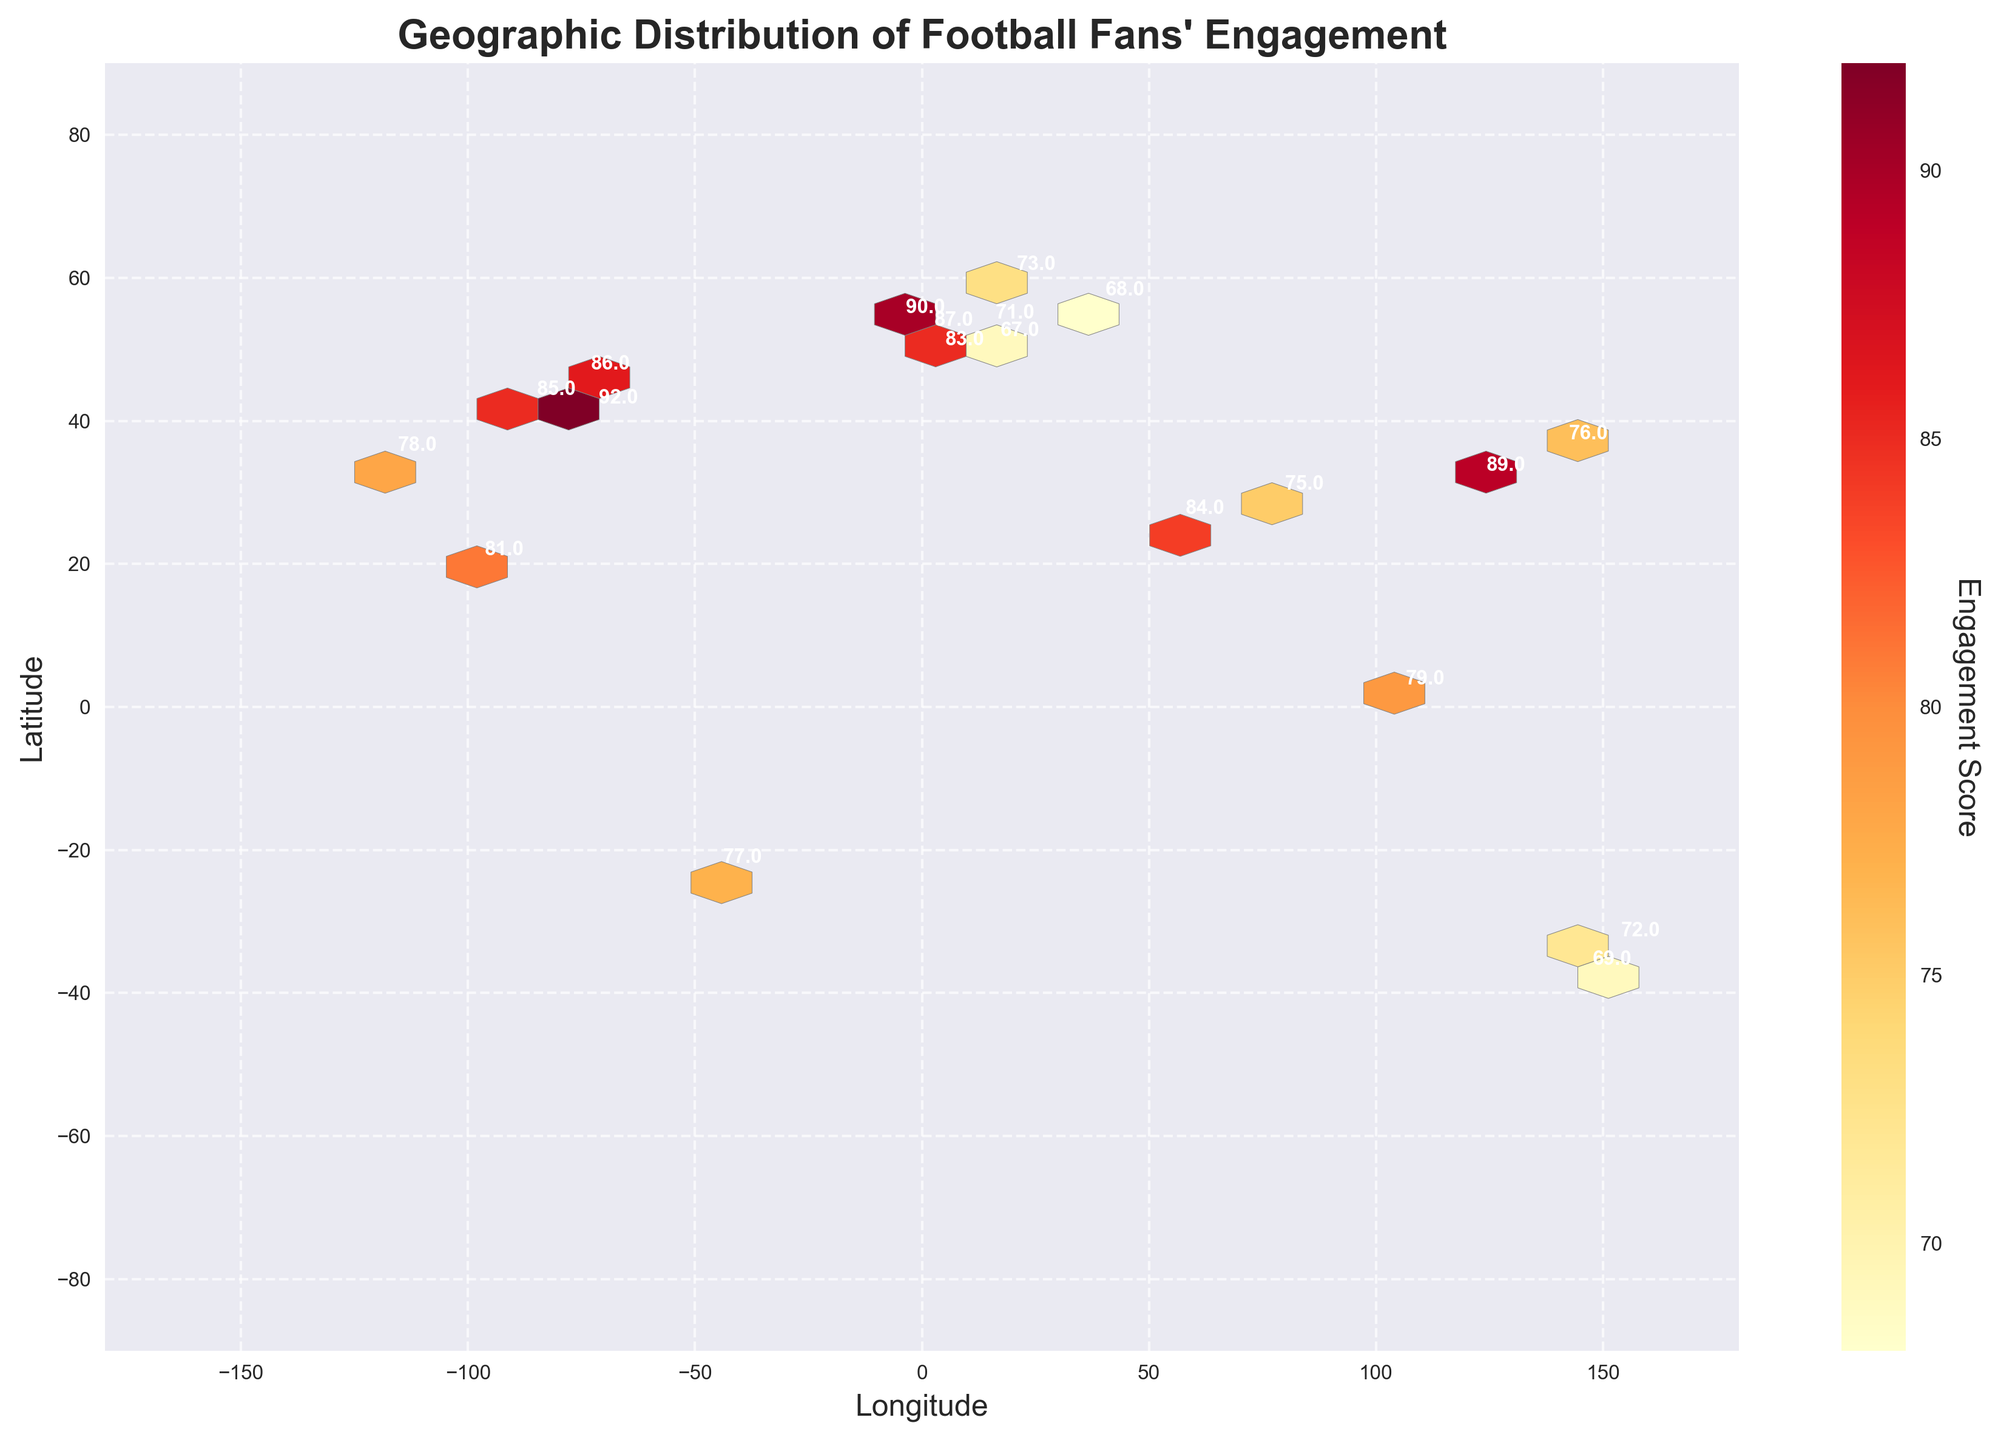What is the title of the figure? The title of the figure is located at the top of the plot. Reading the title from the top of the image, it states "Geographic Distribution of Football Fans' Engagement."
Answer: Geographic Distribution of Football Fans' Engagement What are the units shown on the color bar? The color bar represents the "Engagement Score," which is indicated by the label next to the color bar. By looking at the orientation and label, we can confirm that it measures the engagement of football fans.
Answer: Engagement Score What's the highest engagement score annotated on the map, and where is it located? The highest engagement score is annotated on the map with the score of '92'. By locating the specific annotation and reviewing the coordinates, it is positioned at longitude -74.0060, latitude 40.7128, which corresponds to New York City.
Answer: 92 in New York City How many cities have an engagement score higher than 85? To determine this, scan the annotations on the map and note the cities with scores above 85. We find cities New York (92), London (87), Chicago (85), Shanghai (89), Dublin (90), and Ottawa (86).
Answer: 6 Which city has a lower engagement score, Berlin or Melbourne? By examining the annotated engagement scores for both cities, Berlin has the score '71', whereas Melbourne holds '69'.
Answer: Melbourne Compare the engagement scores between Tokyo and Dubai. Which city has a higher score? The engagement score annotations indicate Tokyo with '76' and Dubai with '84'. By comparing these values, Dubai has a higher score.
Answer: Dubai What's the approximate range of engagement scores shown on the plot? The engagement scores range from 67 to 92, as seen in the annotations of individual cities where the lowest score is 67 (Prague) and the highest is 92 (New York City).
Answer: 67 to 92 Which continent appears to have the densest area of high engagement scores based on the hexbin plot? The heat map indicates reddish colors in regions where high engagement scores are present. By evaluating these regions, particularly North America and Europe show dense high-score activity.
Answer: North America and Europe What is the hexbin plot's grid size? Although not explicitly visible in the plot, one can infer grid size by counting the hexagons across the x and y axes within the confines of the plot. Therefore, approximating 20 based on the visible hexagon structure.
Answer: 20 